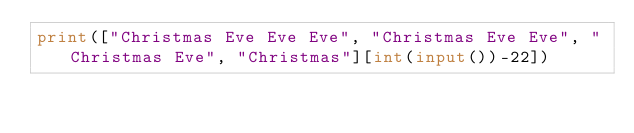Convert code to text. <code><loc_0><loc_0><loc_500><loc_500><_Python_>print(["Christmas Eve Eve Eve", "Christmas Eve Eve", "Christmas Eve", "Christmas"][int(input())-22]) 
</code> 